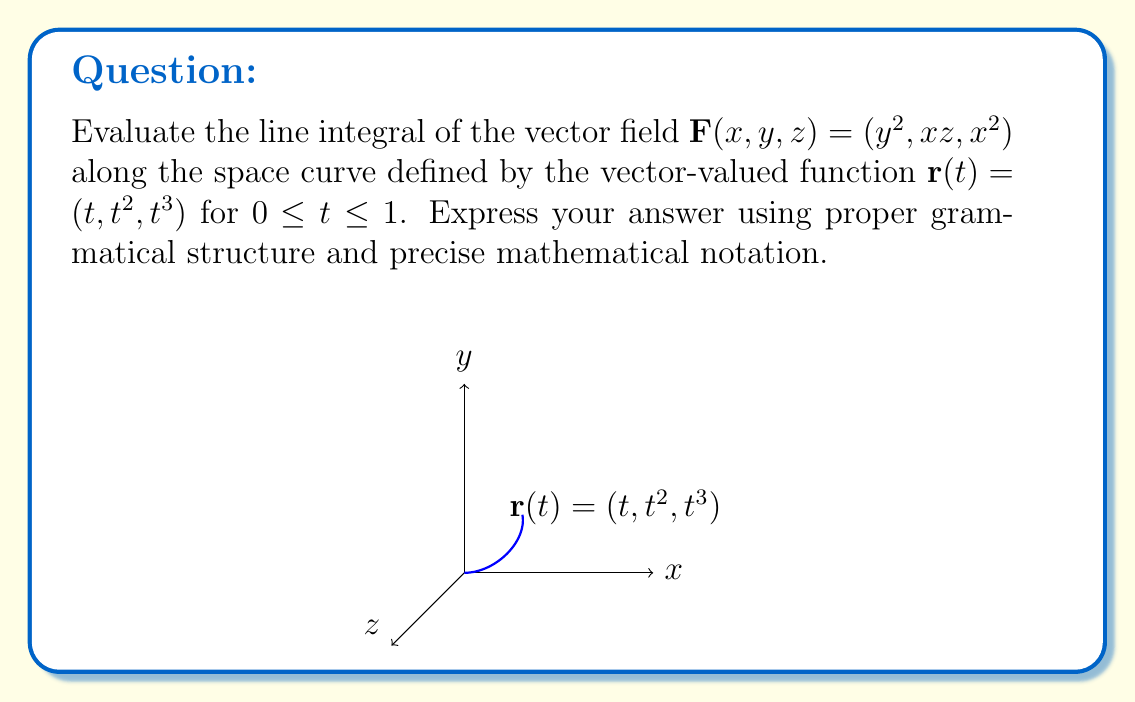Teach me how to tackle this problem. To evaluate the line integral of a vector field along a space curve, we follow these steps:

1) First, we need to find $\mathbf{F}(\mathbf{r}(t))$ by substituting the components of $\mathbf{r}(t)$ into $\mathbf{F}(x,y,z)$:

   $\mathbf{F}(\mathbf{r}(t)) = ((t^2)^2, t \cdot t^3, t^2) = (t^4, t^4, t^2)$

2) Next, we calculate $\frac{d\mathbf{r}}{dt}$:

   $\frac{d\mathbf{r}}{dt} = (1, 2t, 3t^2)$

3) The line integral is given by:

   $\int_C \mathbf{F} \cdot d\mathbf{r} = \int_0^1 \mathbf{F}(\mathbf{r}(t)) \cdot \frac{d\mathbf{r}}{dt} dt$

4) We calculate the dot product inside the integral:

   $\mathbf{F}(\mathbf{r}(t)) \cdot \frac{d\mathbf{r}}{dt} = (t^4, t^4, t^2) \cdot (1, 2t, 3t^2)$
   $= t^4 + 2t^5 + 3t^4 = 4t^4 + 2t^5$

5) Now we integrate from 0 to 1:

   $\int_0^1 (4t^4 + 2t^5) dt = \left[\frac{4t^5}{5} + \frac{2t^6}{6}\right]_0^1$

6) Evaluate the antiderivative at the limits:

   $= \left(\frac{4}{5} + \frac{1}{3}\right) - (0 + 0) = \frac{4}{5} + \frac{1}{3} = \frac{12}{15} + \frac{5}{15} = \frac{17}{15}$

Therefore, the value of the line integral is $\frac{17}{15}$.
Answer: $\frac{17}{15}$ 